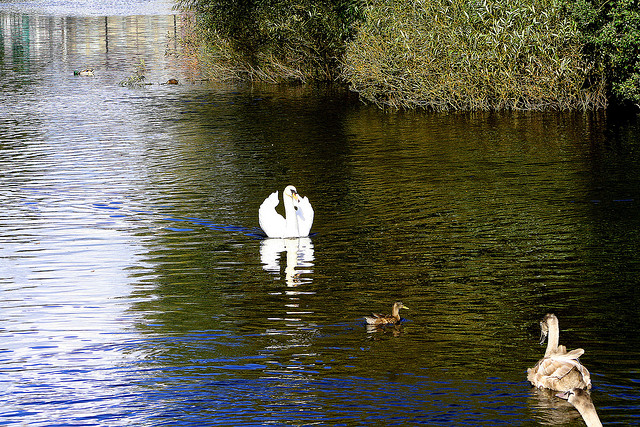What is the smaller bird in between the two larger birds?
A. duck
B. parakeet
C. parrot
D. pigeon The correct answer is 'A', identifying the bird as a duck. The smaller bird seen between the larger birds, which are swans, appears to be a duck due to its size, shape, and water habitat common for ducks. Ducks are frequently observed in water bodies like the one depicted and are distinguished by their medium size and the way they carry their bodies on the water. 